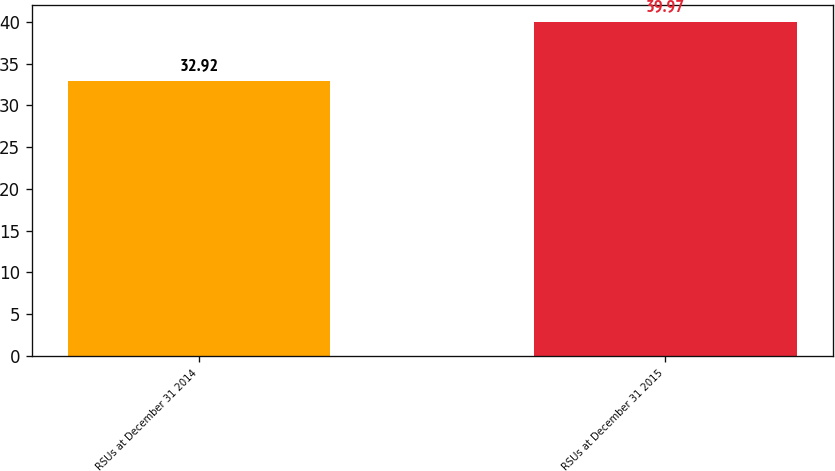Convert chart to OTSL. <chart><loc_0><loc_0><loc_500><loc_500><bar_chart><fcel>RSUs at December 31 2014<fcel>RSUs at December 31 2015<nl><fcel>32.92<fcel>39.97<nl></chart> 